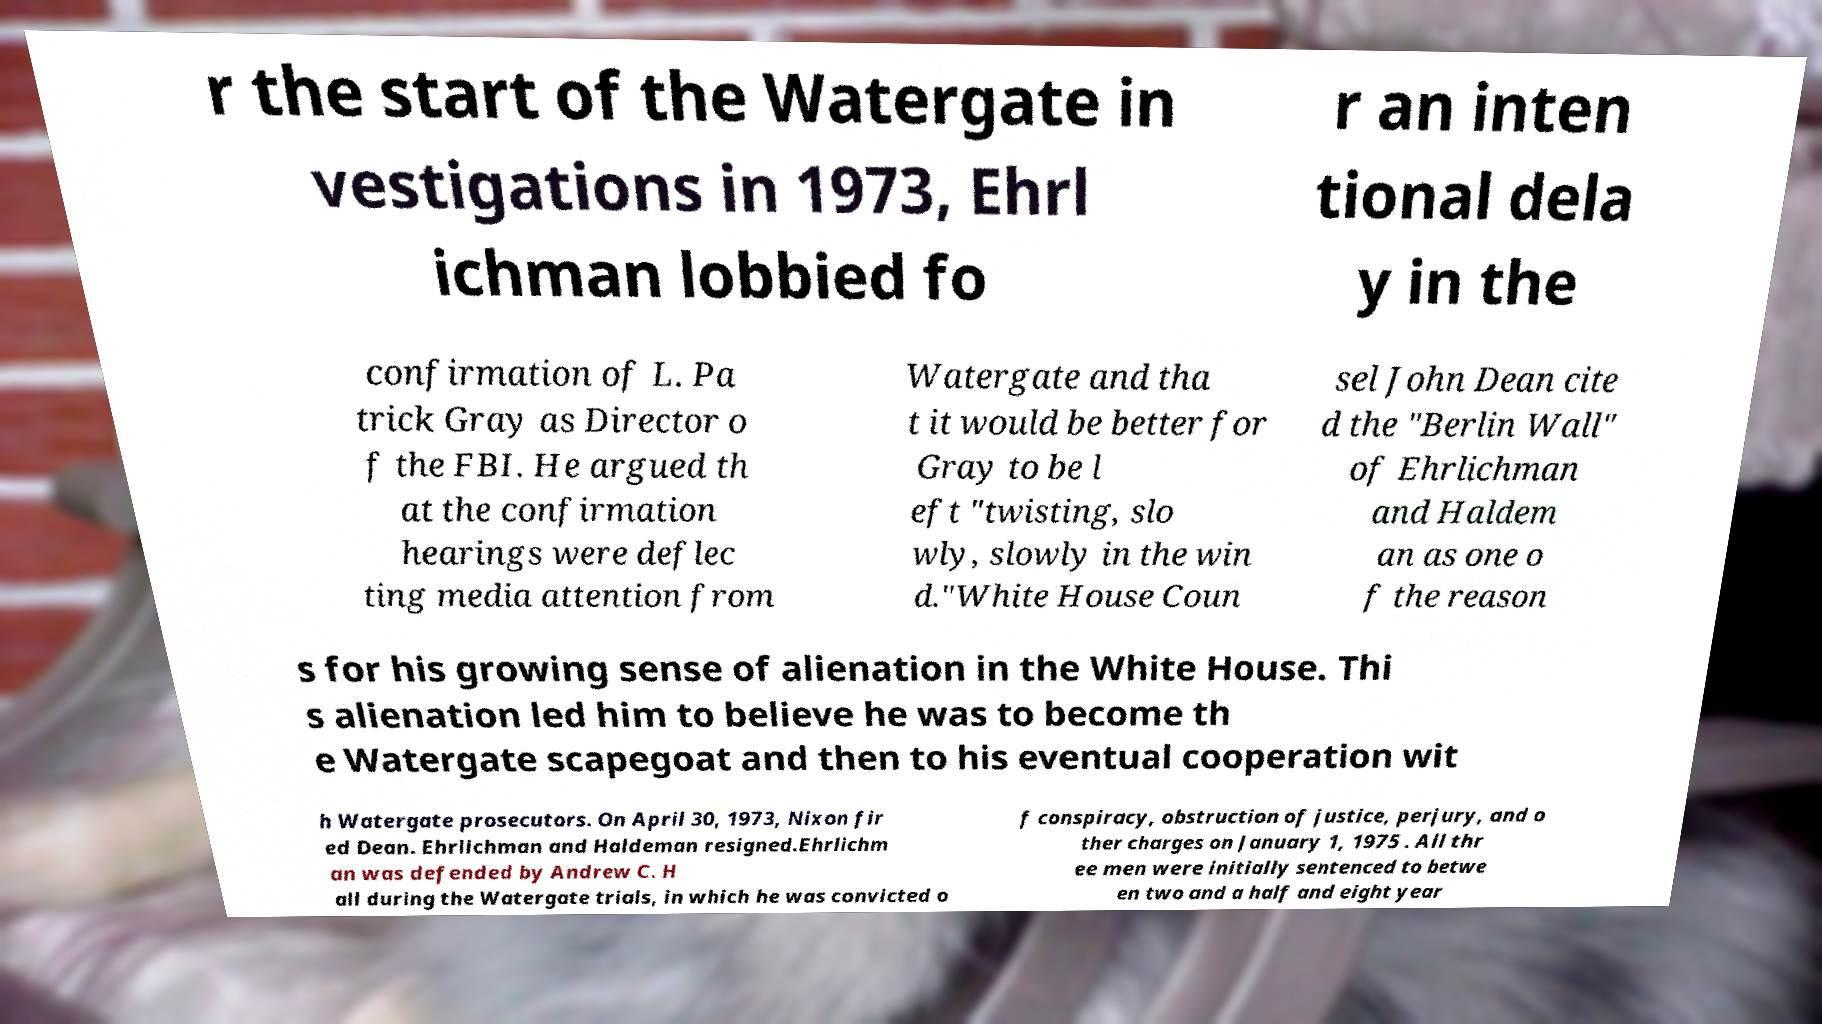There's text embedded in this image that I need extracted. Can you transcribe it verbatim? r the start of the Watergate in vestigations in 1973, Ehrl ichman lobbied fo r an inten tional dela y in the confirmation of L. Pa trick Gray as Director o f the FBI. He argued th at the confirmation hearings were deflec ting media attention from Watergate and tha t it would be better for Gray to be l eft "twisting, slo wly, slowly in the win d."White House Coun sel John Dean cite d the "Berlin Wall" of Ehrlichman and Haldem an as one o f the reason s for his growing sense of alienation in the White House. Thi s alienation led him to believe he was to become th e Watergate scapegoat and then to his eventual cooperation wit h Watergate prosecutors. On April 30, 1973, Nixon fir ed Dean. Ehrlichman and Haldeman resigned.Ehrlichm an was defended by Andrew C. H all during the Watergate trials, in which he was convicted o f conspiracy, obstruction of justice, perjury, and o ther charges on January 1, 1975 . All thr ee men were initially sentenced to betwe en two and a half and eight year 